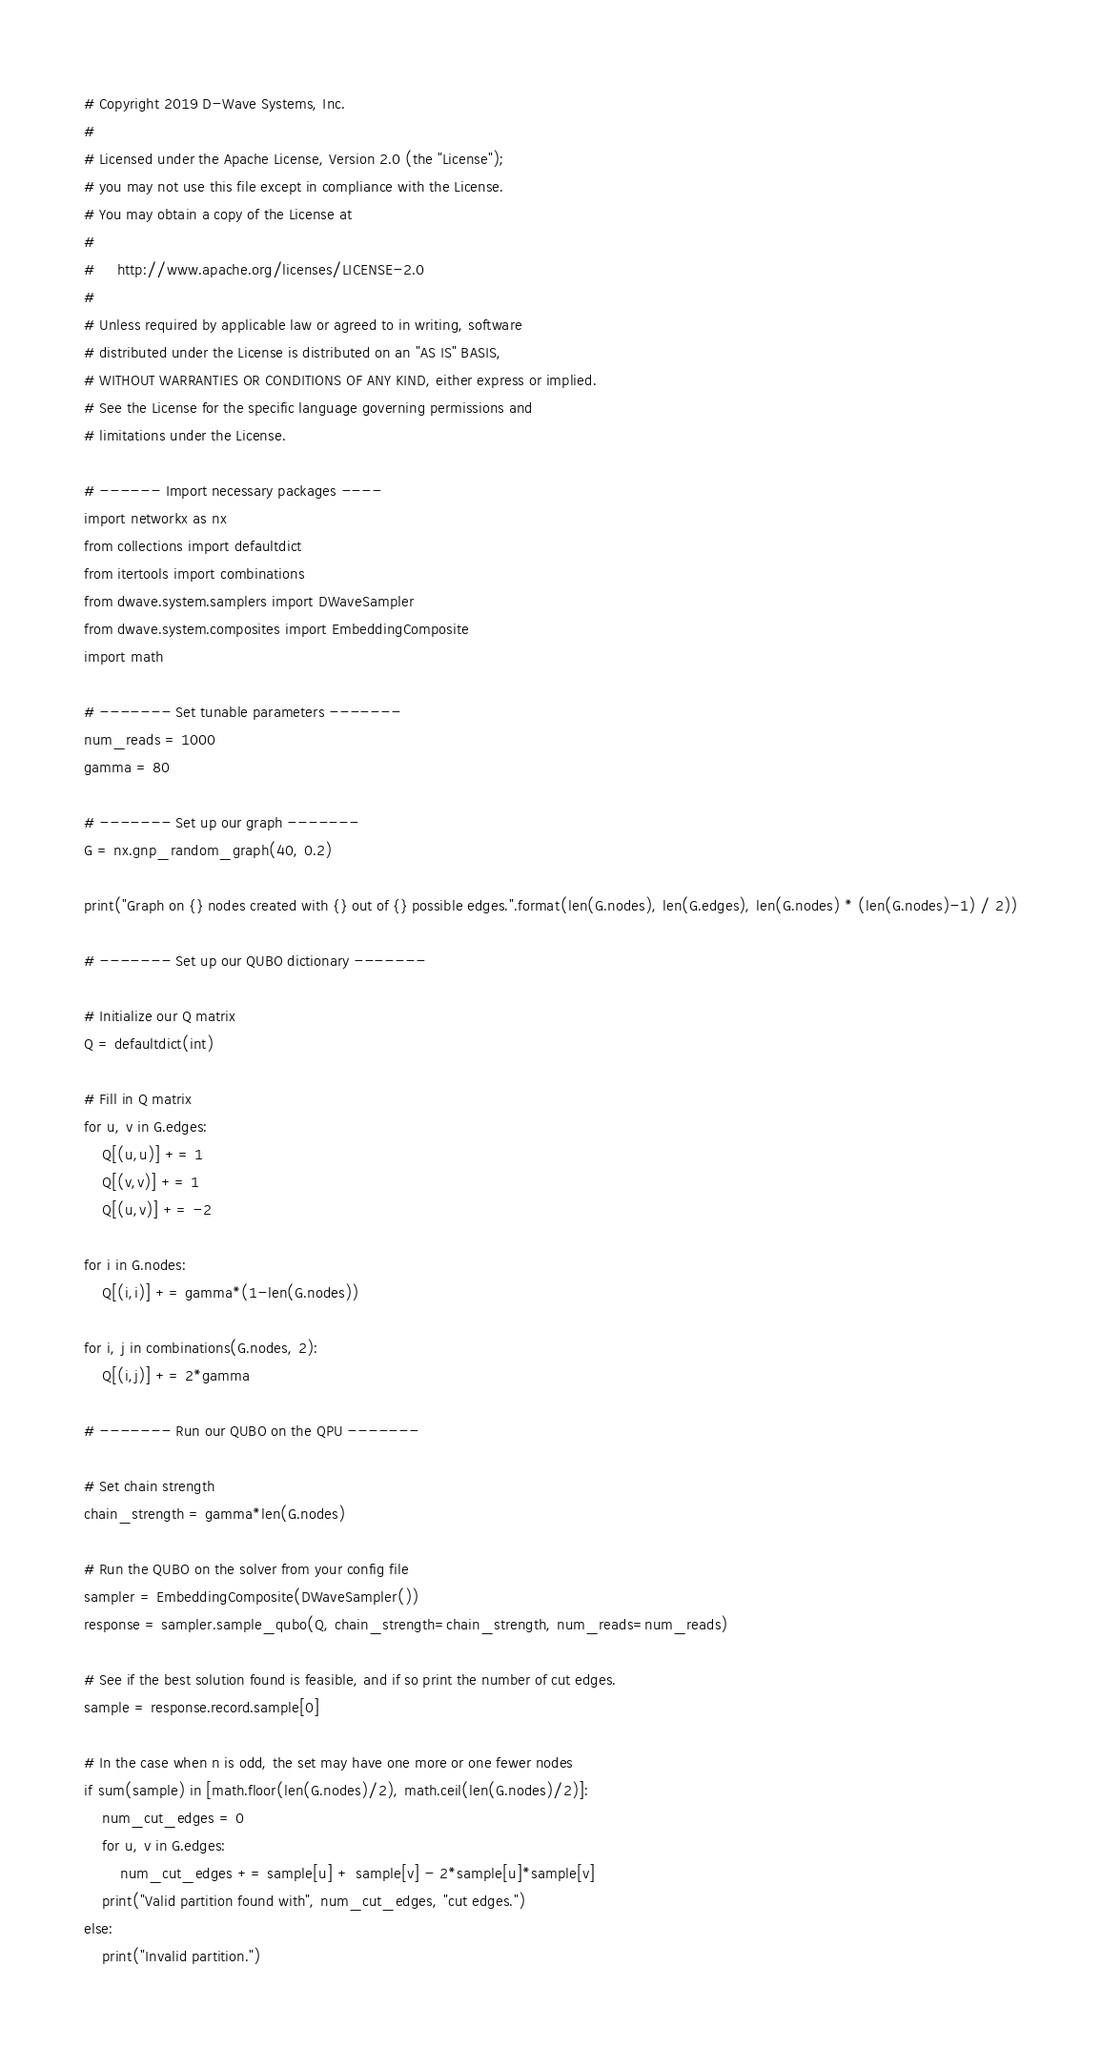<code> <loc_0><loc_0><loc_500><loc_500><_Python_># Copyright 2019 D-Wave Systems, Inc.
#
# Licensed under the Apache License, Version 2.0 (the "License");
# you may not use this file except in compliance with the License.
# You may obtain a copy of the License at
#
#     http://www.apache.org/licenses/LICENSE-2.0
#
# Unless required by applicable law or agreed to in writing, software
# distributed under the License is distributed on an "AS IS" BASIS,
# WITHOUT WARRANTIES OR CONDITIONS OF ANY KIND, either express or implied.
# See the License for the specific language governing permissions and
# limitations under the License.

# ------ Import necessary packages ----
import networkx as nx 
from collections import defaultdict
from itertools import combinations
from dwave.system.samplers import DWaveSampler
from dwave.system.composites import EmbeddingComposite
import math

# ------- Set tunable parameters -------
num_reads = 1000
gamma = 80

# ------- Set up our graph -------
G = nx.gnp_random_graph(40, 0.2)

print("Graph on {} nodes created with {} out of {} possible edges.".format(len(G.nodes), len(G.edges), len(G.nodes) * (len(G.nodes)-1) / 2))

# ------- Set up our QUBO dictionary -------

# Initialize our Q matrix
Q = defaultdict(int)

# Fill in Q matrix
for u, v in G.edges:
    Q[(u,u)] += 1
    Q[(v,v)] += 1
    Q[(u,v)] += -2

for i in G.nodes:
    Q[(i,i)] += gamma*(1-len(G.nodes))

for i, j in combinations(G.nodes, 2):
	Q[(i,j)] += 2*gamma

# ------- Run our QUBO on the QPU -------

# Set chain strength
chain_strength = gamma*len(G.nodes)

# Run the QUBO on the solver from your config file
sampler = EmbeddingComposite(DWaveSampler())
response = sampler.sample_qubo(Q, chain_strength=chain_strength, num_reads=num_reads)

# See if the best solution found is feasible, and if so print the number of cut edges.
sample = response.record.sample[0]

# In the case when n is odd, the set may have one more or one fewer nodes
if sum(sample) in [math.floor(len(G.nodes)/2), math.ceil(len(G.nodes)/2)]:
    num_cut_edges = 0
    for u, v in G.edges:
        num_cut_edges += sample[u] + sample[v] - 2*sample[u]*sample[v]
    print("Valid partition found with", num_cut_edges, "cut edges.")
else:
    print("Invalid partition.")</code> 